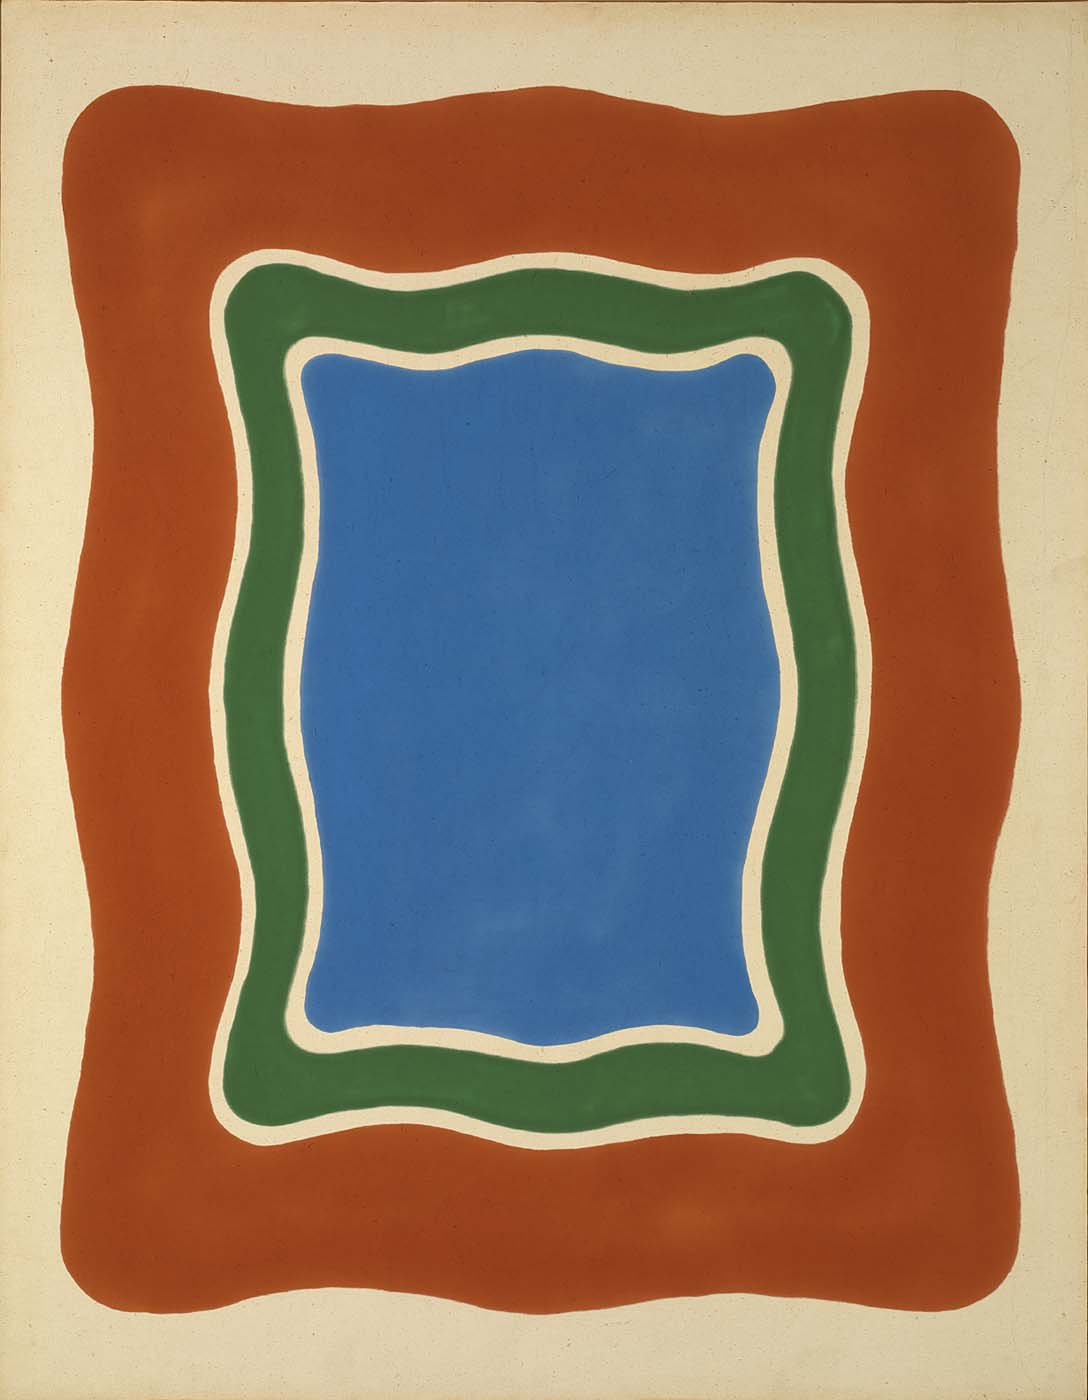Analyze the image in a comprehensive and detailed manner. The image features an abstract art style, characterized by its minimalist yet bold use of geometric shapes and a vivid color palette. The central focus is a bold blue rectangle with softly undulating borders, evoking a tranquil sea or a vast expanse of sky. This blue area is encased in a green border that both contrasts with and complements the blue, implying a natural harmony like that of earth meeting water or grassy fields under a clear sky. An outermost border in warm orange adds a dynamic contrast, reminiscent of a sunset surrounding a serene landscape. This composition’s layering technique coupled with the curvaceous lines softens the geometric rigidity typically associated with such forms, offering a more organic impression. The use of primary colors along with green invokes both a sense of primary simplicity and a deeper connection with elemental aspects of nature. This striking use of color and form could be suggestive of the emotional impact of natural beauty on human perception, challenging the viewer to explore their personal reactions to such a simple yet profound visual representation. 